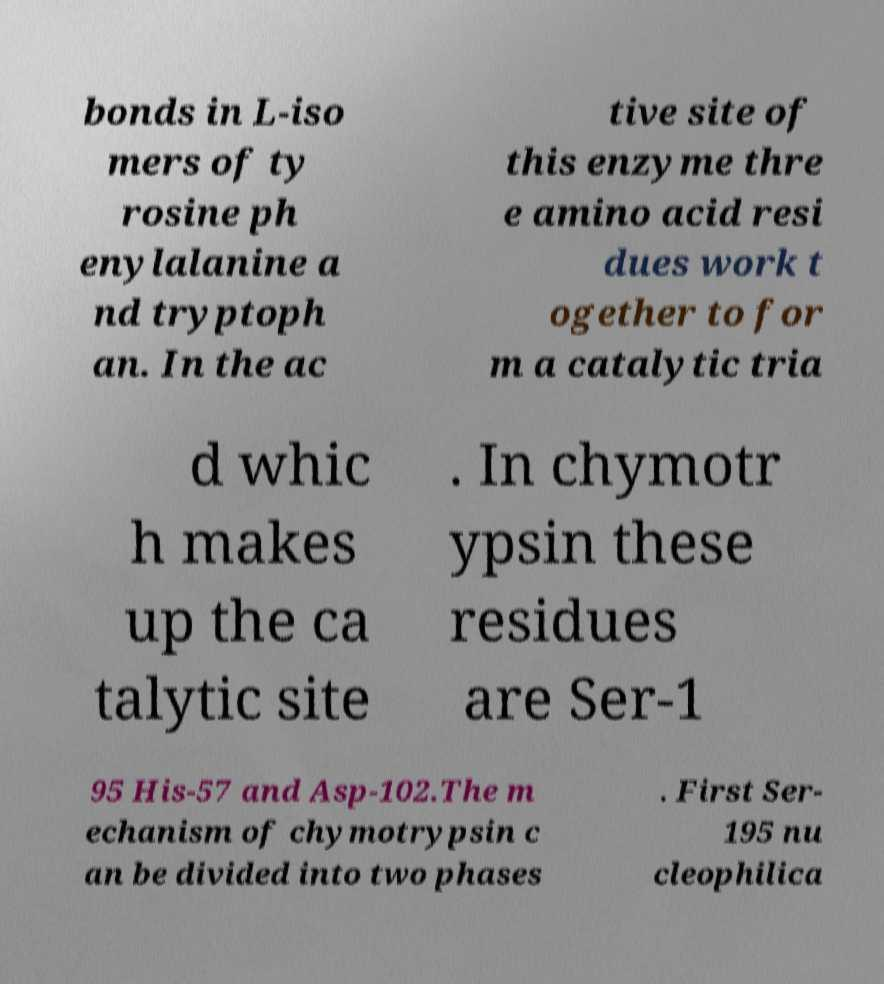Could you assist in decoding the text presented in this image and type it out clearly? bonds in L-iso mers of ty rosine ph enylalanine a nd tryptoph an. In the ac tive site of this enzyme thre e amino acid resi dues work t ogether to for m a catalytic tria d whic h makes up the ca talytic site . In chymotr ypsin these residues are Ser-1 95 His-57 and Asp-102.The m echanism of chymotrypsin c an be divided into two phases . First Ser- 195 nu cleophilica 